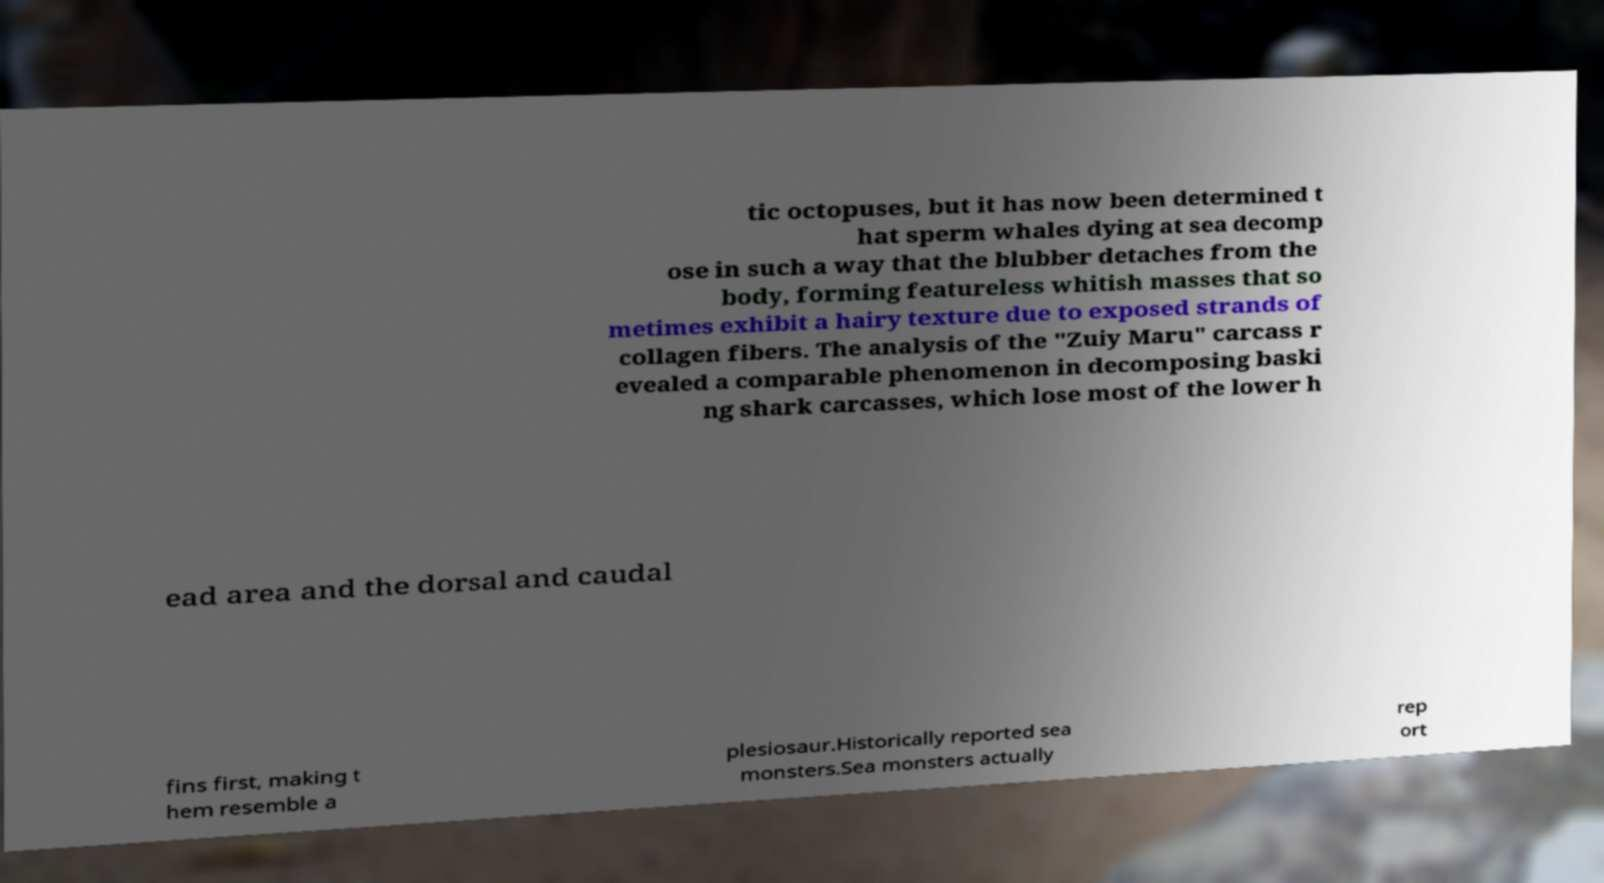Could you assist in decoding the text presented in this image and type it out clearly? tic octopuses, but it has now been determined t hat sperm whales dying at sea decomp ose in such a way that the blubber detaches from the body, forming featureless whitish masses that so metimes exhibit a hairy texture due to exposed strands of collagen fibers. The analysis of the "Zuiy Maru" carcass r evealed a comparable phenomenon in decomposing baski ng shark carcasses, which lose most of the lower h ead area and the dorsal and caudal fins first, making t hem resemble a plesiosaur.Historically reported sea monsters.Sea monsters actually rep ort 